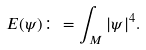<formula> <loc_0><loc_0><loc_500><loc_500>E ( \psi ) \colon = \int _ { M } | \psi | ^ { 4 } .</formula> 